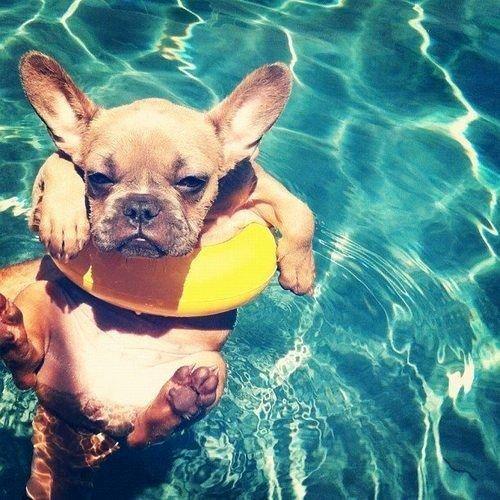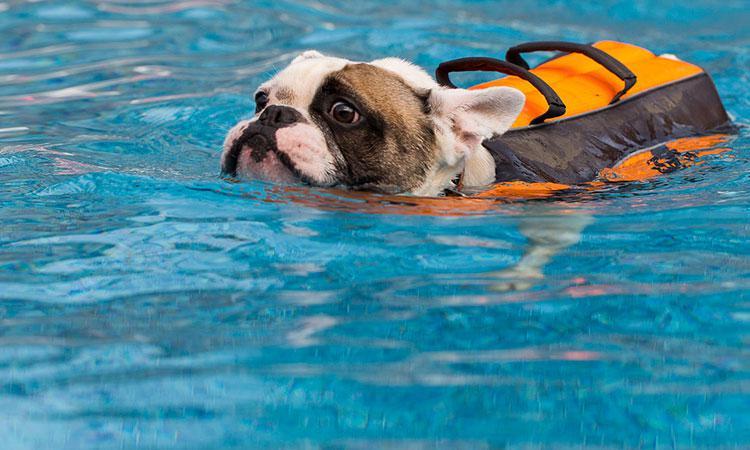The first image is the image on the left, the second image is the image on the right. Examine the images to the left and right. Is the description "One of the images shows a dog floating in a pool while using an inner tube." accurate? Answer yes or no. Yes. The first image is the image on the left, the second image is the image on the right. For the images displayed, is the sentence "Each image contains one dog in a swimming pool, and the right image shows a bulldog swimming at a leftward angle and wearing an orange life vest." factually correct? Answer yes or no. Yes. 